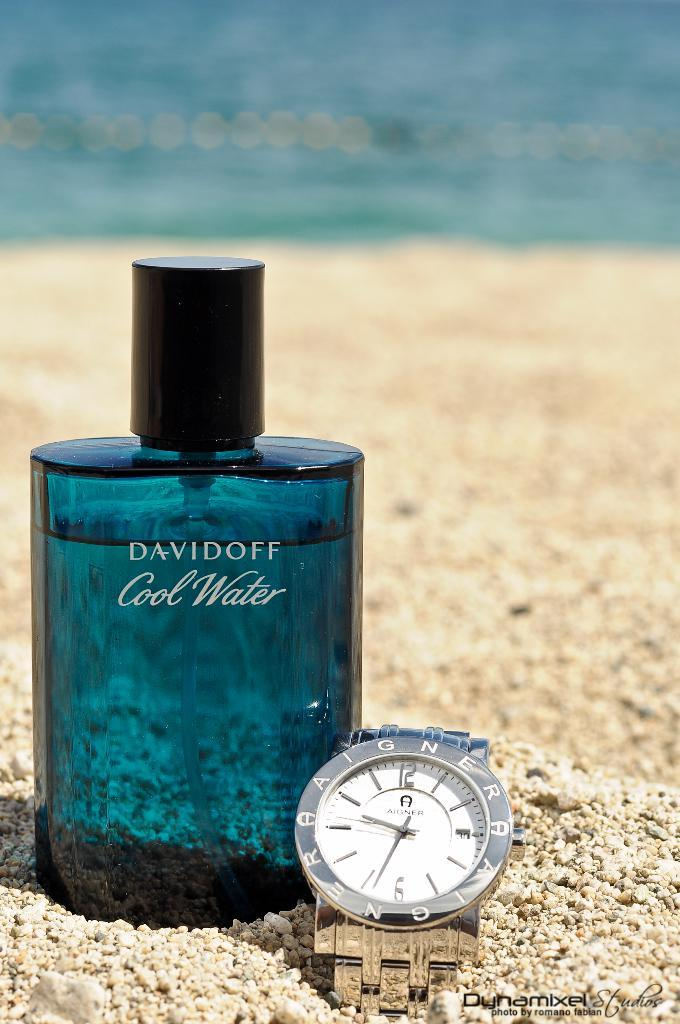What is the main object in the image? There is a perfume bottle in the image. What other object with text can be seen in the image? There is a watch with text in the image. What type of natural elements are visible in the background of the image? There is sand and water visible in the background of the image. What type of calculator can be seen in the image? There is no calculator present in the image. What type of net is used for catching fish in the image? There is no net or fishing activity depicted in the image. 